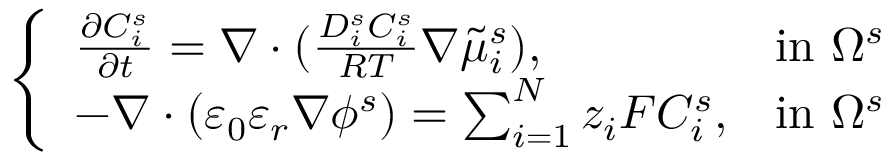<formula> <loc_0><loc_0><loc_500><loc_500>\left \{ \begin{array} { l l } { \frac { \partial C _ { i } ^ { s } } { \partial t } = \nabla \cdot ( \frac { D _ { i } ^ { s } C _ { i } ^ { s } } { R T } \nabla \tilde { \mu } _ { i } ^ { s } ) , } & { i n \Omega ^ { s } } \\ { - \nabla \cdot ( \varepsilon _ { 0 } \varepsilon _ { r } \nabla \phi ^ { s } ) = \sum _ { i = 1 } ^ { N } z _ { i } F C _ { i } ^ { s } , } & { i n \Omega ^ { s } } \end{array}</formula> 